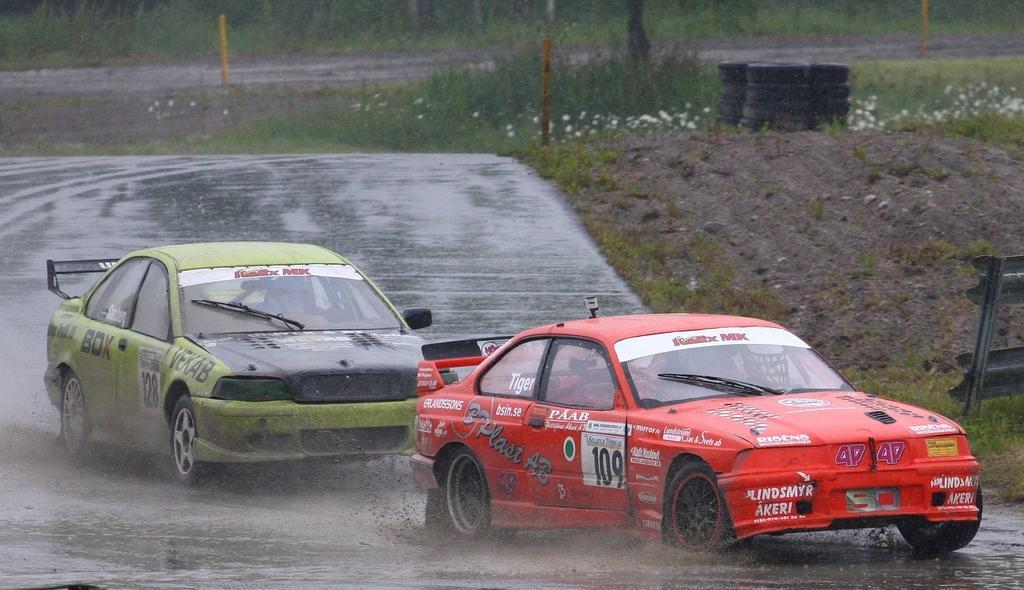Please provide a concise description of this image. In this image we can see two cars on the road. One is in red color and the other one is in green color. Background of the image grassy land and tyres are present. Right side of the image one board is there. 